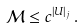Convert formula to latex. <formula><loc_0><loc_0><loc_500><loc_500>\mathcal { M } \leq c ^ { | U | _ { j } } \, .</formula> 